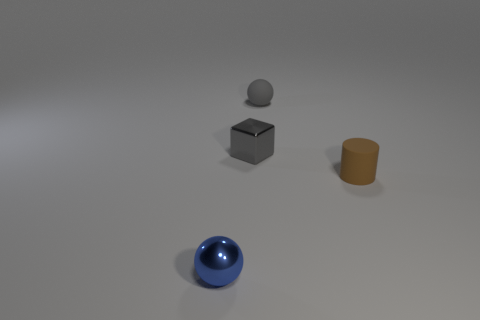Add 3 gray blocks. How many objects exist? 7 Subtract all gray spheres. How many spheres are left? 1 Subtract all cubes. How many objects are left? 3 Subtract 0 cyan cubes. How many objects are left? 4 Subtract all blue cylinders. Subtract all green cubes. How many cylinders are left? 1 Subtract all tiny metal spheres. Subtract all blue metal objects. How many objects are left? 2 Add 3 blue metallic things. How many blue metallic things are left? 4 Add 4 small gray cubes. How many small gray cubes exist? 5 